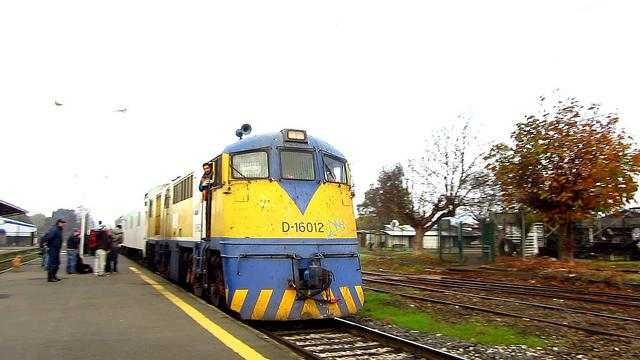What are the people waiting to do? Please explain your reasoning. board. The people are standing on a platform next to a train which indicates they are likely there for the purposes of getting on the train. 